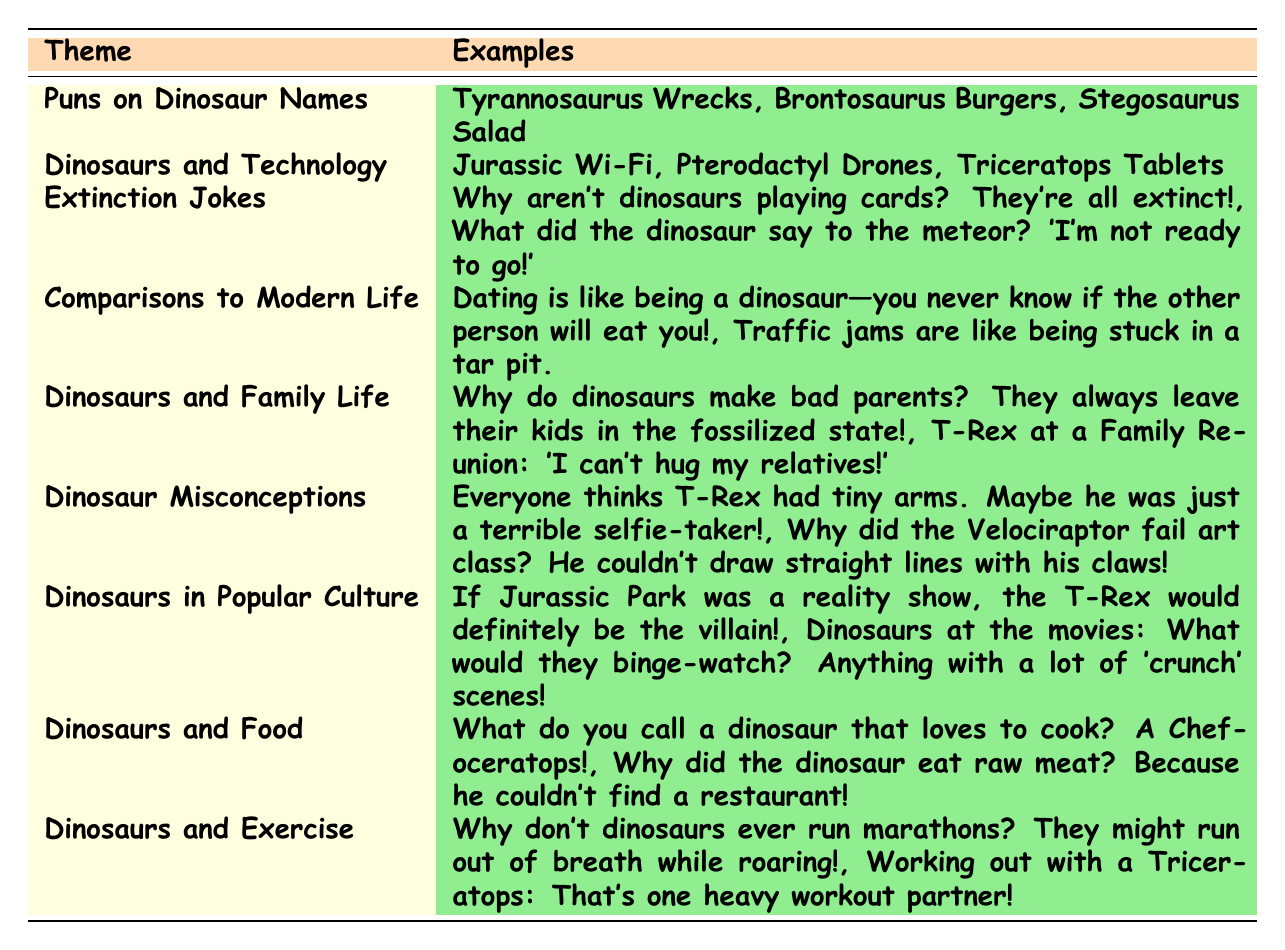What is the theme that includes jokes about dinosaurs and food? The table clearly shows various themes, and under the column labeled "Theme," we find "Dinosaurs and Food" listed.
Answer: Dinosaurs and Food How many themes are mentioned in the table? By counting all the rows in the table under the theme column, we see there are 9 distinct themes listed.
Answer: 9 Which theme has an example related to technology? Looking at the examples provided in the table, we find that "Dinosaurs and Technology" includes examples like "Jurassic Wi-Fi."
Answer: Dinosaurs and Technology Are there any jokes about dinosaur misconceptions? In the table, the theme "Dinosaur Misconceptions" is explicitly mentioned with relevant examples, indicating that there are jokes in this category.
Answer: Yes What is the first example listed under the theme of "Extinction Jokes"? Referring to the theme "Extinction Jokes," the first example given is "Why aren’t dinosaurs playing cards? They’re all extinct!"
Answer: Why aren’t dinosaurs playing cards? They’re all extinct! If you had to categorize "What do you call a dinosaur that loves to cook?" which theme would it fall under? The question refers to the text of the example, which is found under the theme "Dinosaurs and Food," therefore it is categorized there.
Answer: Dinosaurs and Food What is the total number of examples listed under the theme "Dinosaurs and Exercise"? The theme "Dinosaurs and Exercise" has 2 examples mentioned, so we just count them to get the total.
Answer: 2 Which theme do you think would appeal more to parents? Analyzing the table, the theme "Dinosaurs and Family Life" contains jokes that are directly relevant to parenting, making it more appealing to parents.
Answer: Dinosaurs and Family Life Are there more themes related to technology or food? By examining the table, we see that there is one theme for "Dinosaurs and Technology" and one for "Dinosaurs and Food," thus they are equal.
Answer: They are equal What do the examples under "Comparisons to Modern Life" suggest about dating? The examples indicate that dating is humorously compared to experiences of dinosaurs, implying it's unpredictable and possibly dangerous, mimicking the themes in the jokes.
Answer: Humorously unpredictable 